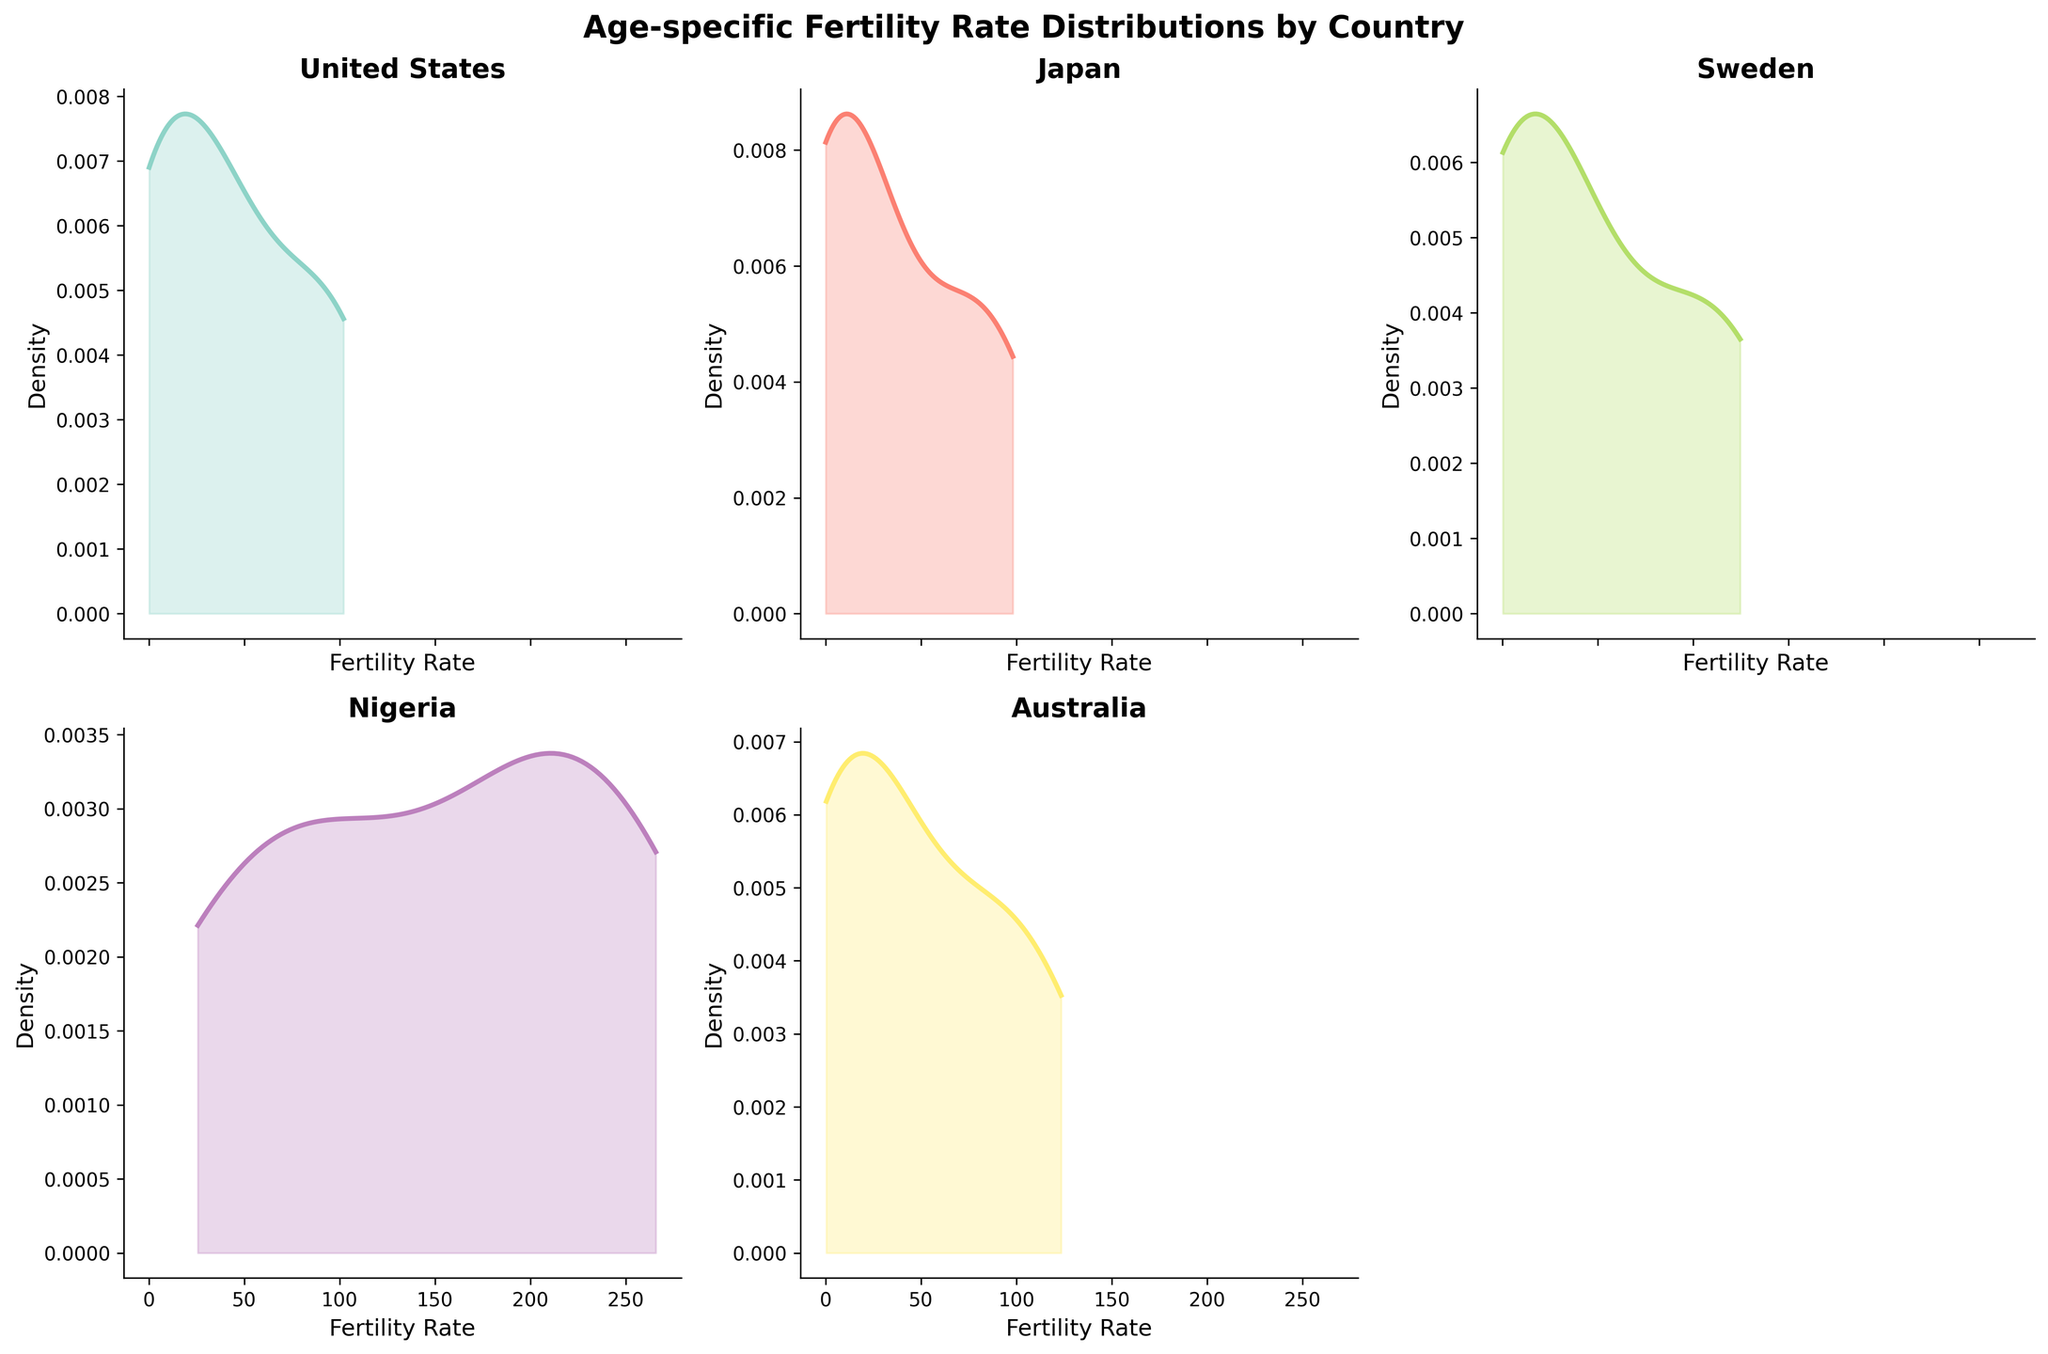How many countries are represented in the density plots? There are 5 subplots, each titled with a different country name: United States, Japan, Sweden, Nigeria, and Australia, indicating that 5 countries are represented.
Answer: 5 Which country shows the highest peak in the density plot? Nigeria’s density plot has the tallest peak, suggesting the highest density of a specific fertility rate range among the countries shown.
Answer: Nigeria What is the title of the figure? The title is located at the top of the figure and reads "Age-specific Fertility Rate Distributions by Country."
Answer: Age-specific Fertility Rate Distributions by Country Which country appears to have the widest spread of fertility rates? Nigeria’s density plot covers a wide range from lower to higher fertility rates, indicating the widest spread of fertility rates.
Answer: Nigeria In which countries does the fertility rate density go above 100? Both Sweden and Nigeria have density plots that show values above a fertility rate of 100, as indicated by the spread of their curves.
Answer: Sweden, Nigeria Which country has the most narrow peak in the density plot? Japan’s density plot is more narrowly peaked compared to the others, indicating less variation in fertility rates.
Answer: Japan What age range is depicted in the density plots for each country? All subplots share the same age range on the x-axis, which is labeled "Fertility Rate," implying ages typically range from 15 to 45.
Answer: 15 to 45 Which country has the lowest maximum fertility rate according to the plots? Based on the plots, Japan has the lowest maximum fertility rate since its curve does not reach as high as the others.
Answer: Japan Are there any countries where the density near the zero fertility rate is the highest? The United States and Australia have density plots that peak closer to zero fertility rates compared to other countries.
Answer: United States, Australia How does the shape of Sweden’s density plot compare with that of Australia’s? Sweden’s density plot shows a higher peak and a more varied spread across different fertility rates, while Australia’s plot has a lower peak and a less varied spread.
Answer: Sweden’s plot is higher and more varied, Australia's is lower and less varied 